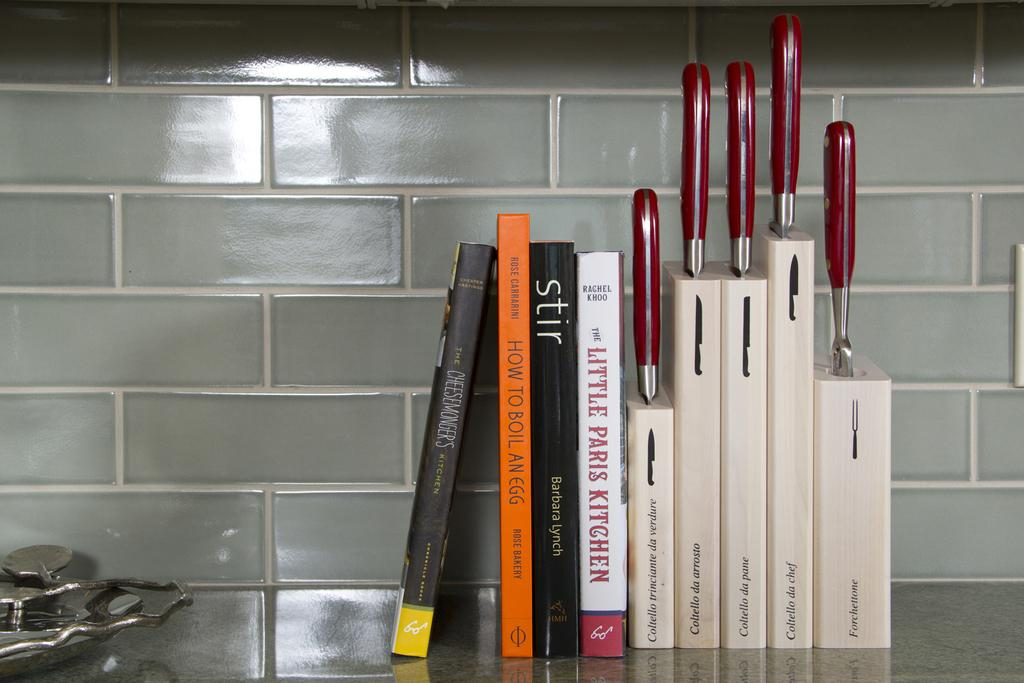<image>
Provide a brief description of the given image. Kitchen counter with knives and a host of books such as Stir by Barbara Lynch. 